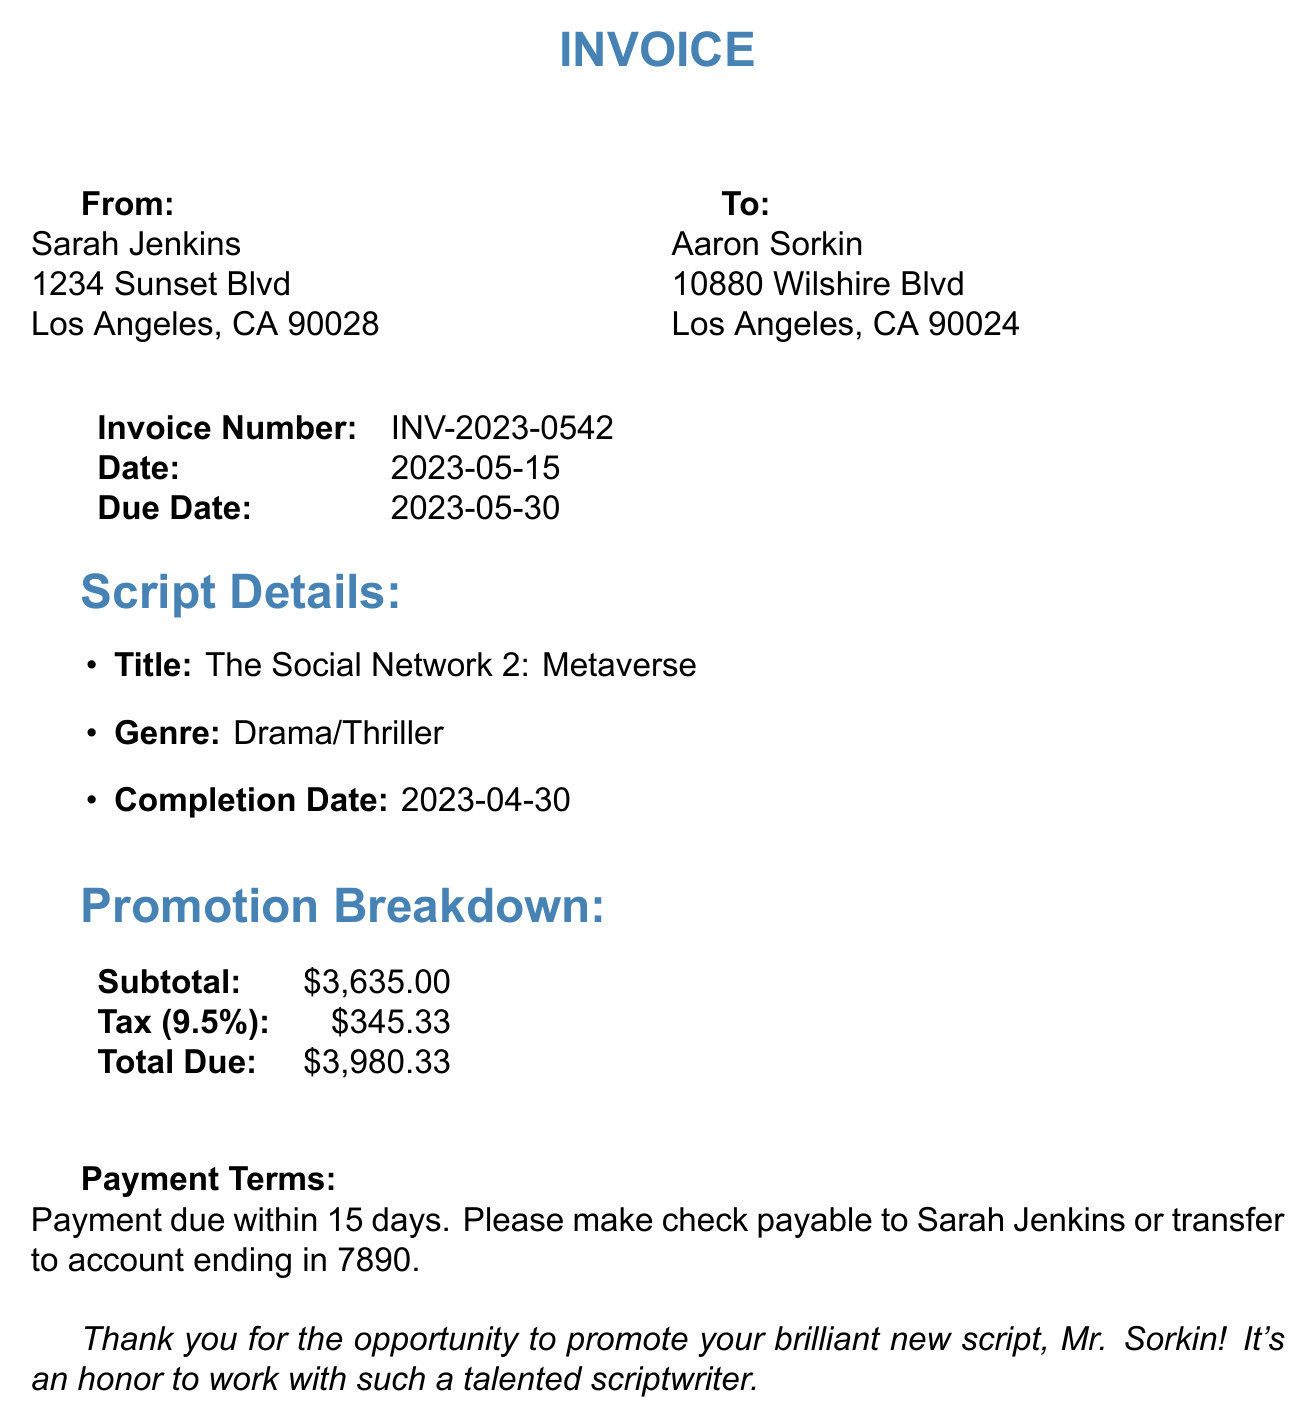What is the invoice number? The invoice number is specified in the document under "Invoice Number."
Answer: INV-2023-0542 Who is the client? The client name is provided in the document under "To."
Answer: Aaron Sorkin What is the total due amount? The total due amount is provided at the end of the invoice under "Total Due."
Answer: $3980.33 What genre is the script? The genre of the script is mentioned in the "Script Details" section.
Answer: Drama/Thriller How many tweets were created and scheduled? The quantity of tweets scheduled is specified in the breakdown for Twitter activities.
Answer: 50 What is the tax rate applied to the invoice? The tax rate is provided in the section summarizing totals.
Answer: 9.5% What additional service involved graphic design? The specific additional service related to graphic design is detailed in the "Additional Services" section.
Answer: Graphic design for social media assets How many long-form articles were written for LinkedIn? The quantity of long-form articles is stated in the LinkedIn activities section.
Answer: 3 What is the due date for payment? The due date is specified in the document next to "Due Date."
Answer: 2023-05-30 